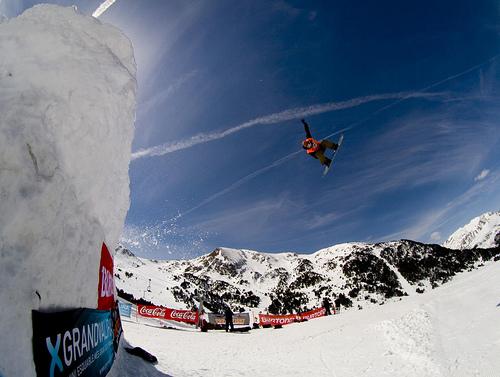What sport is the man doing?
Give a very brief answer. Snowboarding. Is advertising visible?
Write a very short answer. Yes. Would cowabunga be a proper exclamation for this scene?
Answer briefly. Yes. Is this a dangerous sport?
Keep it brief. Yes. 